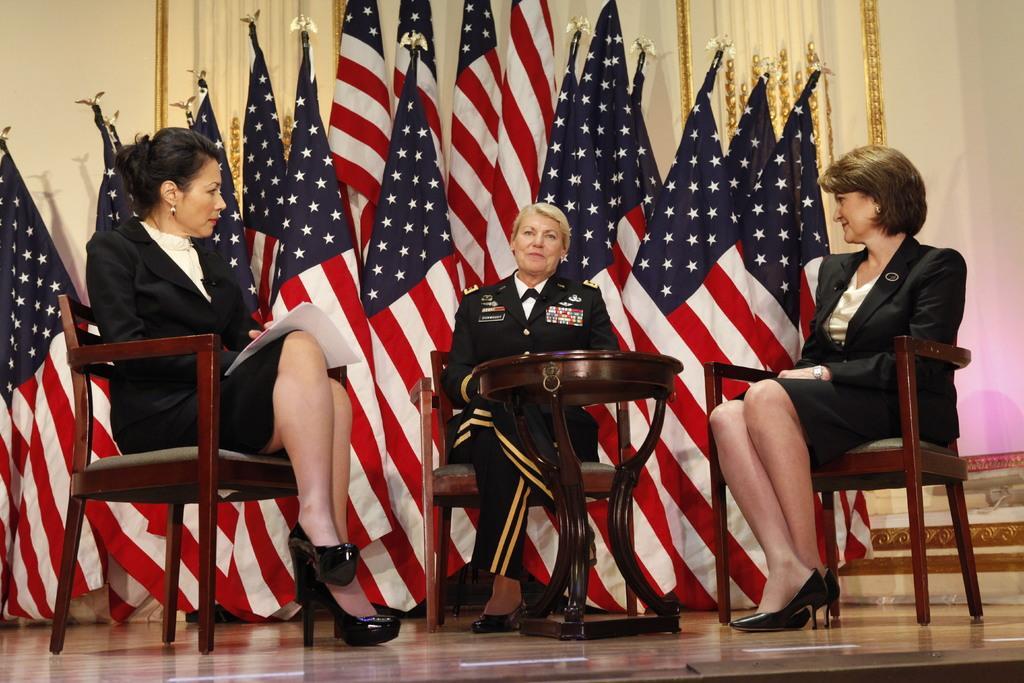Please provide a concise description of this image. Three ladies with the black jacket are sitting on the chair. in the middle there is a table. At the back of them there are many flags. 